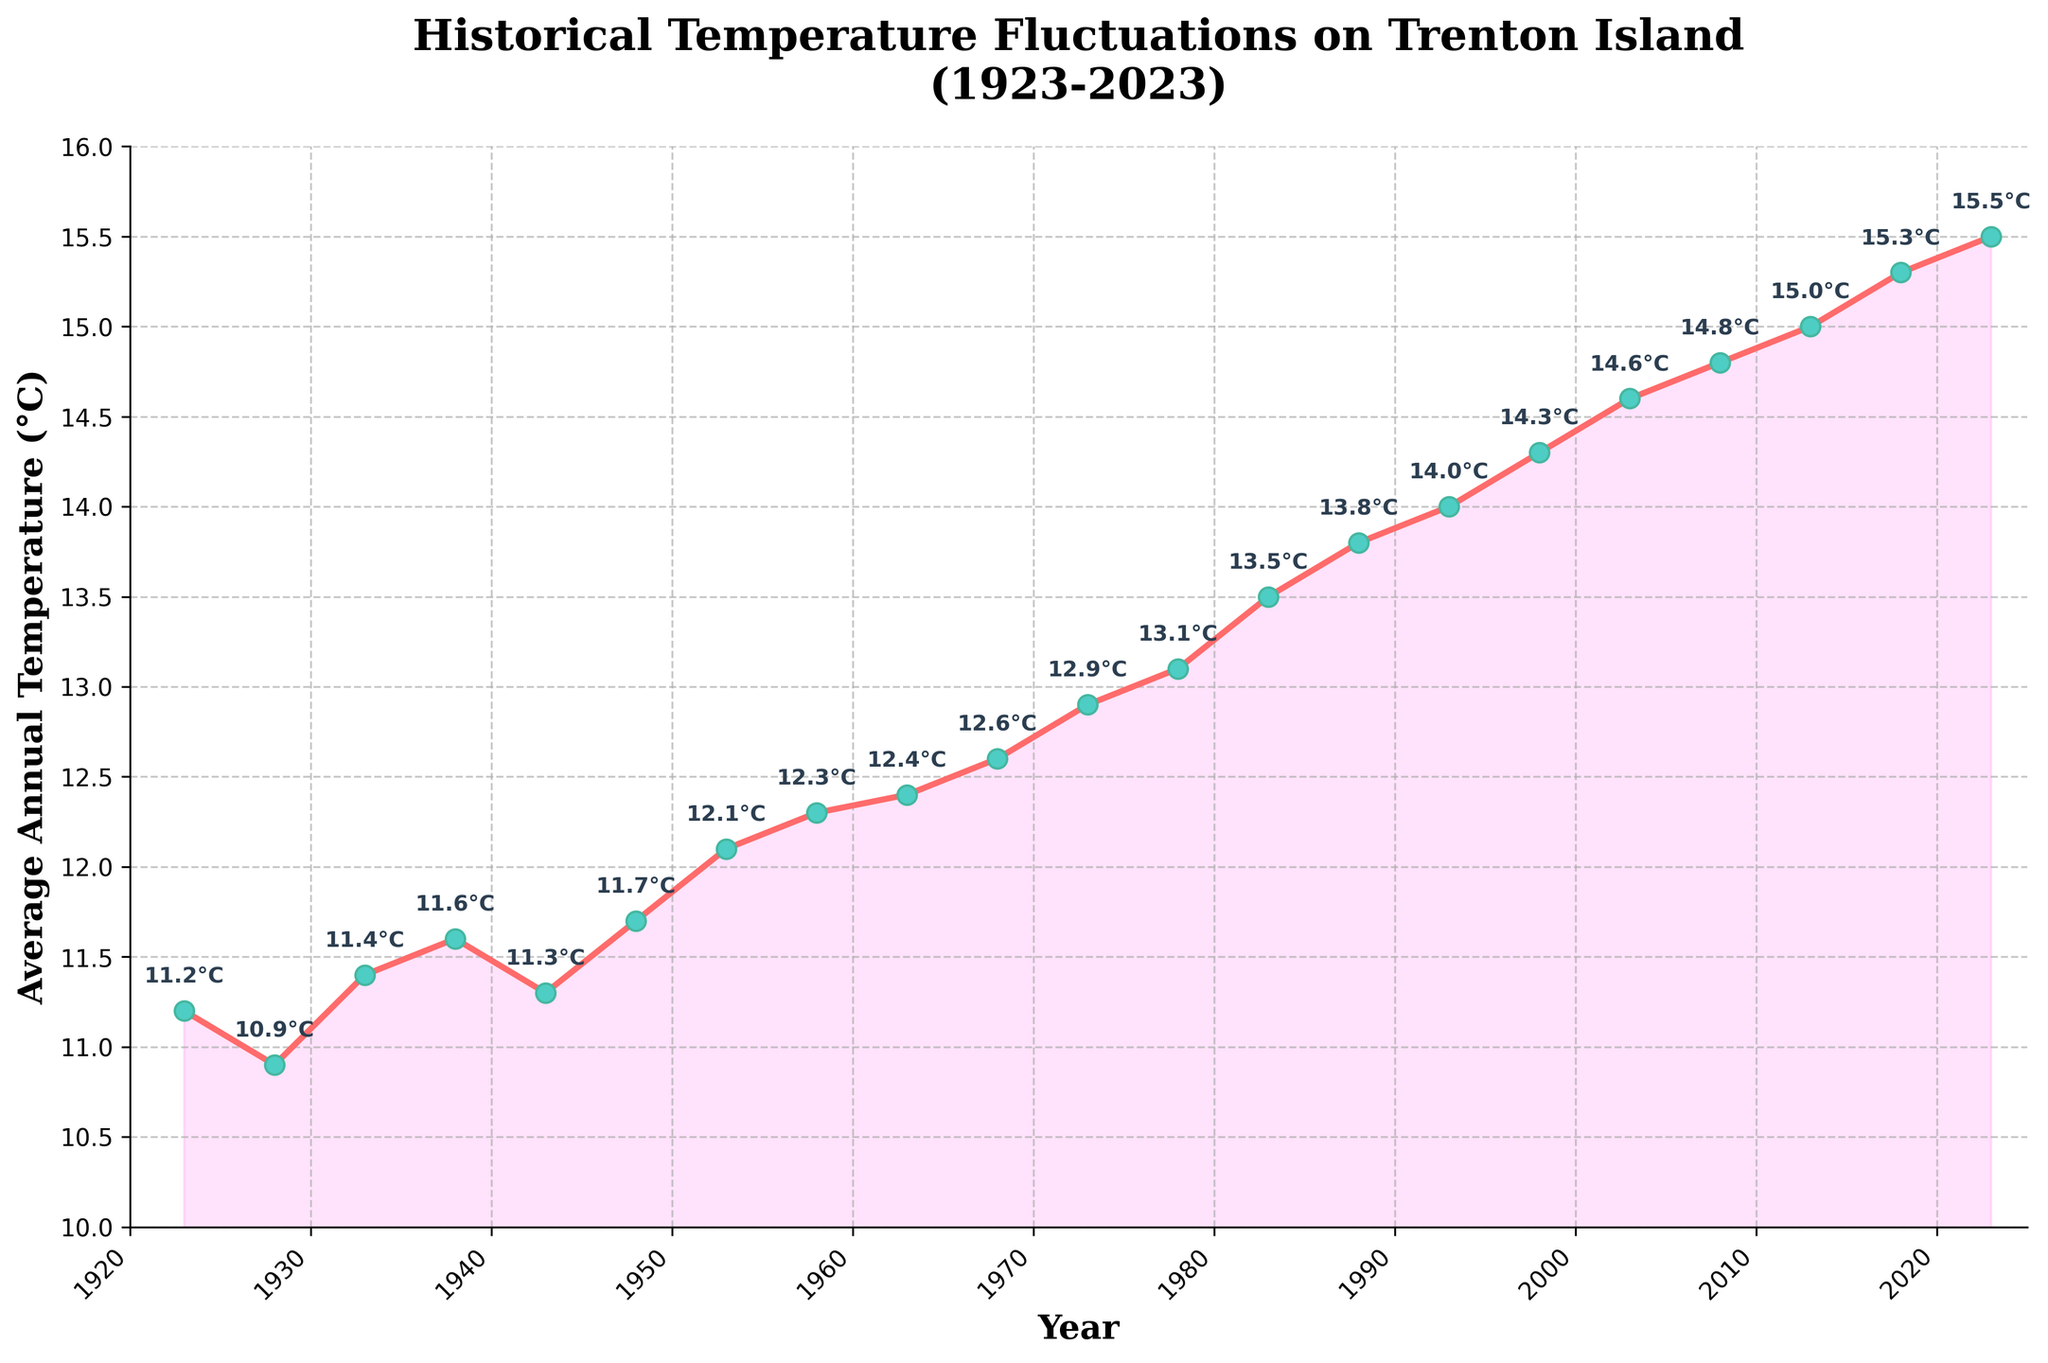What's the title of the figure? The title is often placed at the top center of the figure. In this case, it clearly reads "Historical Temperature Fluctuations on Trenton Island (1923-2023)"
Answer: Historical Temperature Fluctuations on Trenton Island (1923-2023) Which year shows the highest average annual temperature? The plot shows a time series of annual temperatures marked at each year. The highest point on the y-axis corresponds to the last data point marked at 2023.
Answer: 2023 What is the average annual temperature in 1978? Identify the data point corresponding to the year 1978 and read off the temperature value annotated next to it.
Answer: 13.1°C How does the average annual temperature in 2003 compare to that in 1953? Locate the temperatures for both 2003 and 1953 on the plot and compare their values. 2003 shows a higher temperature than 1953.
Answer: 2003 is higher By how much did the average annual temperature increase from 1923 to 2018? Find the temperatures for 1923 (11.2°C) and 2018 (15.3°C), then calculate the difference: 15.3°C - 11.2°C = 4.1°C
Answer: 4.1°C Between which consecutive years is the largest temperature increase observed? Examine the differences between consecutive yearly temperatures and identify the largest increase. The largest jump appears between 1948 (11.7°C) and 1953 (12.1°C), an increase of 4°C. Note that the increase of 3°C between 2008 (14.8°C) and 2013 (15.0°C) comes second. We can also compare it to 1988 (13.8°C) and 1993 (14.0°C) with the same results
Answer: 1948 to 1953 What is the average temperature over the entire period (1923-2023)? Sum all the temperature values and divide by the number of years. The temperatures sum to 275.3°C over 21 years, resulting in an average of 275.3°C / 21 ≈ 13.1°C
Answer: ~13.1°C Which decade saw the most noticeable increase in temperature? By examining the plot, the period from the 1980s to the 2000s shows the most noticeable temperature rise, especially around the late 1980s and onwards.
Answer: 1980s to 2000s What could be a possible reason for the temperature fluctuation pattern seen in this time series? While not directly answerable from the plot alone, historical knowledge suggests that factors such as industrialization, greenhouse gas emissions, and climate change could explain the warming trend observed.
Answer: Climate change and industrialization 